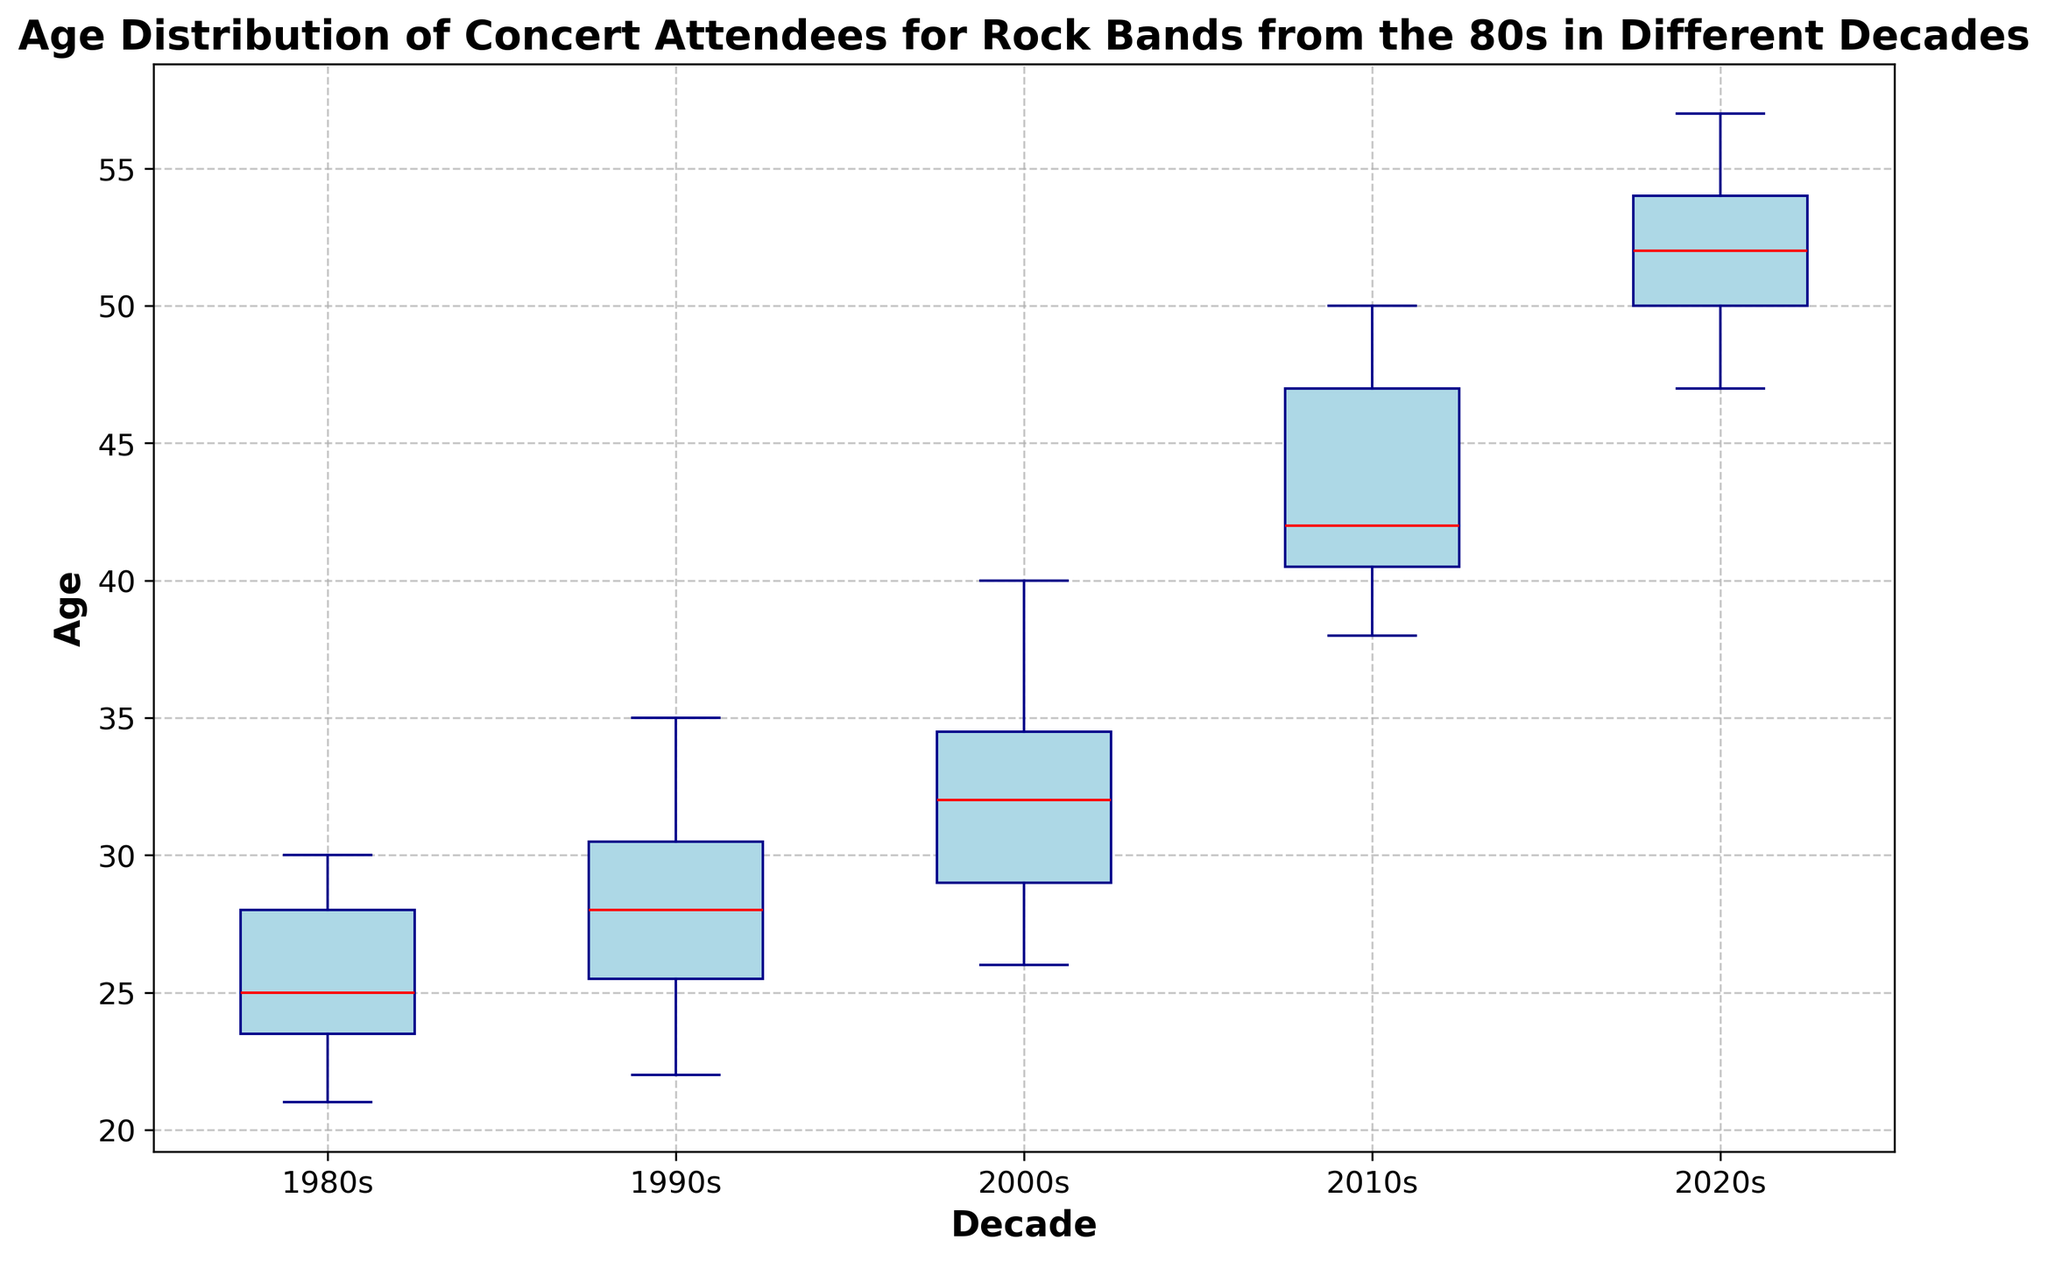What's the median age for attendees in the 2010s? The median is the middle value when the ages are arranged in order. In the box plot, this is represented by the line inside the box for the 2010s.
Answer: Approximately 42 How does the median age of attendees in the 2020s compare with the 1980s? The median age in the 2020s is visually higher in the box plot compared to the median age for the 1980s.
Answer: 2020s median > 1980s median Which decade shows the largest interquartile range (IQR) for attendees' ages? The IQR is the length of the box in the box plot. The decade with the longest box represents the largest IQR.
Answer: 2020s Are there any outliers in the 1980s decade? Outliers in a box plot are represented by the green dots outside the whiskers. There are no green dots outside the whiskers for the 1980s.
Answer: No What is the range of ages in the 2000s? The range is the difference between the maximum and minimum ages shown by the whiskers of the box plot for the 2000s.
Answer: 26 to 40 How does the spread of ages in the 1990s compare to the 2010s? The spread is indicated by the length from the minimum whisker to the maximum whisker. The 2010s show a wider spread compared to the 1990s.
Answer: 2010s > 1990s Which decade has the oldest attendees on average? The average can be approximated by looking at the overall central tendency and whiskers. The 2020s have the oldest ages shown in the plot.
Answer: 2020s Identify the decade with the youngest median age. The median age is shown by the line in the middle of each box. The 1980s have the lowest median line.
Answer: 1980s What visual clue indicates the central tendency of ages is increasing over the decades? The median lines inside the boxes move upwards as the decades progress. The line represents the central tendency.
Answer: Median lines increasing 